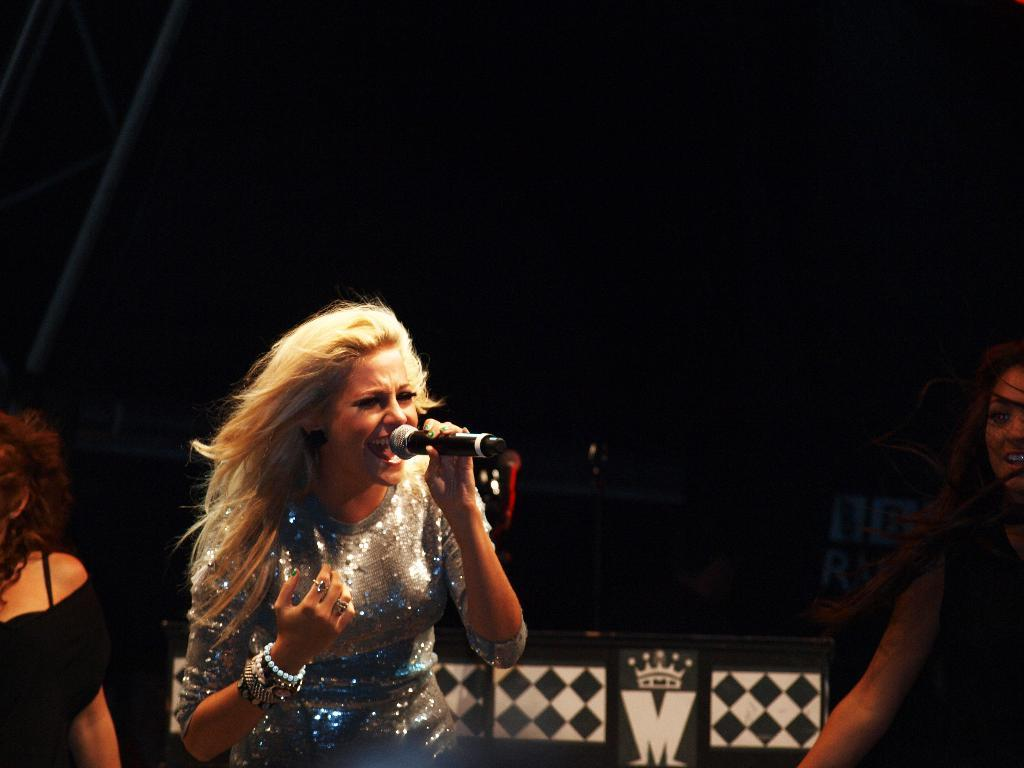What is the woman in the image doing? The woman is singing in the image. What is the woman holding while singing? The woman is holding a microphone in her hand. Can you describe the other person visible in the image? There is another woman standing in the background. How many people are visible in the image? There are two people visible in the image, the woman singing and the woman standing in the background. What type of baseball is the woman wearing in the image? There is no baseball present in the image, and the woman is not wearing any baseball-related clothing or accessories. How many beads are visible on the woman's necklace in the image? There is no necklace or beads visible in the image. 